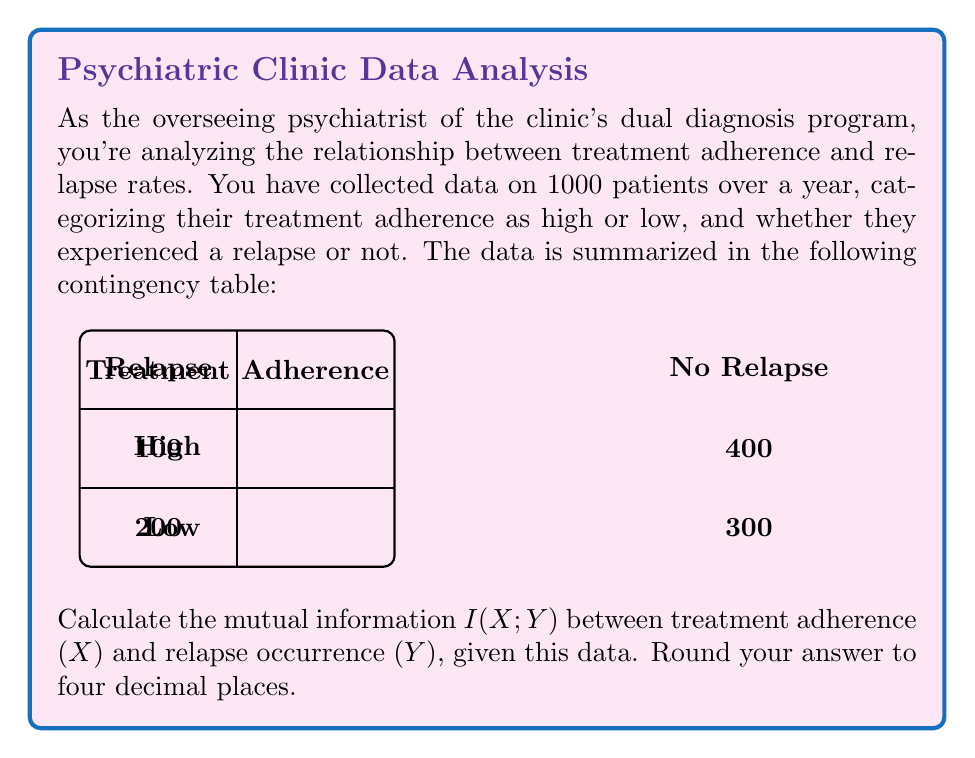Give your solution to this math problem. To calculate the mutual information $I(X;Y)$, we'll follow these steps:

1) First, we need to calculate the probabilities:
   $P(X=\text{High}) = 500/1000 = 0.5$
   $P(X=\text{Low}) = 500/1000 = 0.5$
   $P(Y=\text{Relapse}) = 300/1000 = 0.3$
   $P(Y=\text{No Relapse}) = 700/1000 = 0.7$
   $P(X=\text{High}, Y=\text{Relapse}) = 100/1000 = 0.1$
   $P(X=\text{High}, Y=\text{No Relapse}) = 400/1000 = 0.4$
   $P(X=\text{Low}, Y=\text{Relapse}) = 200/1000 = 0.2$
   $P(X=\text{Low}, Y=\text{No Relapse}) = 300/1000 = 0.3$

2) The formula for mutual information is:
   $$I(X;Y) = \sum_{x \in X} \sum_{y \in Y} P(x,y) \log_2 \left(\frac{P(x,y)}{P(x)P(y)}\right)$$

3) Let's calculate each term:
   For $X=\text{High}, Y=\text{Relapse}$:
   $0.1 \log_2 (0.1 / (0.5 * 0.3)) = 0.1 \log_2 (0.6667) = -0.0541$

   For $X=\text{High}, Y=\text{No Relapse}$:
   $0.4 \log_2 (0.4 / (0.5 * 0.7)) = 0.4 \log_2 (1.1429) = 0.0641$

   For $X=\text{Low}, Y=\text{Relapse}$:
   $0.2 \log_2 (0.2 / (0.5 * 0.3)) = 0.2 \log_2 (1.3333) = 0.0884$

   For $X=\text{Low}, Y=\text{No Relapse}$:
   $0.3 \log_2 (0.3 / (0.5 * 0.7)) = 0.3 \log_2 (0.8571) = -0.0541$

4) Sum all these terms:
   $I(X;Y) = -0.0541 + 0.0641 + 0.0884 - 0.0541 = 0.0443$ bits

5) Rounding to four decimal places: 0.0443 bits
Answer: 0.0443 bits 